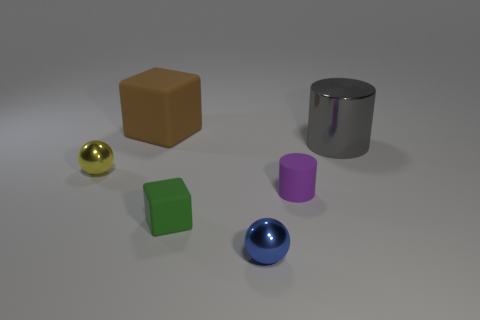There is a rubber block in front of the yellow metal object; is there a large gray shiny object left of it? no 